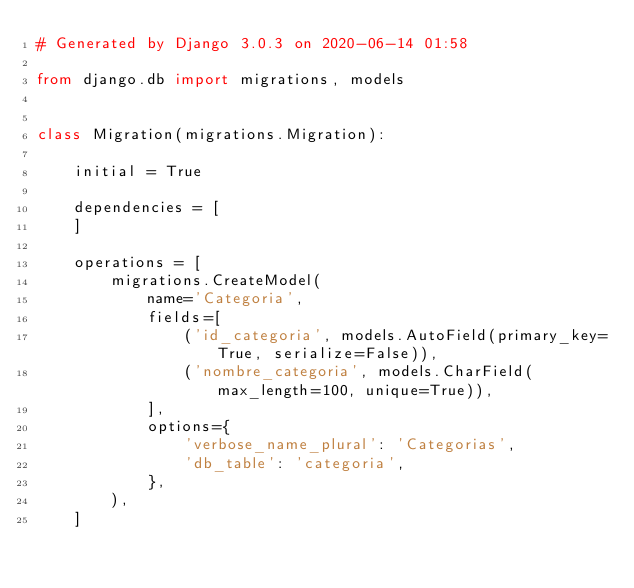<code> <loc_0><loc_0><loc_500><loc_500><_Python_># Generated by Django 3.0.3 on 2020-06-14 01:58

from django.db import migrations, models


class Migration(migrations.Migration):

    initial = True

    dependencies = [
    ]

    operations = [
        migrations.CreateModel(
            name='Categoria',
            fields=[
                ('id_categoria', models.AutoField(primary_key=True, serialize=False)),
                ('nombre_categoria', models.CharField(max_length=100, unique=True)),
            ],
            options={
                'verbose_name_plural': 'Categorias',
                'db_table': 'categoria',
            },
        ),
    ]
</code> 